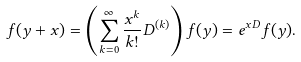<formula> <loc_0><loc_0><loc_500><loc_500>f ( y + x ) = \left ( \sum _ { k = 0 } ^ { \infty } \frac { x ^ { k } } { k ! } D ^ { ( k ) } \right ) f ( y ) = e ^ { x D } f ( y ) .</formula> 